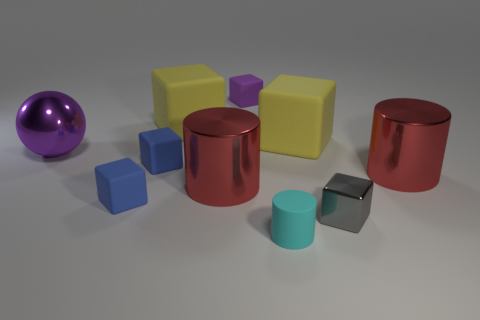There is a tiny thing that is the same color as the large ball; what is it made of?
Give a very brief answer. Rubber. There is a purple object that is the same size as the cyan cylinder; what is its shape?
Offer a very short reply. Cube. What color is the cylinder that is to the left of the purple cube?
Your answer should be compact. Red. What number of things are cubes that are behind the shiny ball or metallic cylinders right of the cyan cylinder?
Give a very brief answer. 4. Is the size of the gray object the same as the cyan rubber cylinder?
Provide a short and direct response. Yes. How many balls are big red things or large shiny objects?
Make the answer very short. 1. What number of metal objects are in front of the sphere and on the left side of the small gray block?
Provide a short and direct response. 1. Does the cyan cylinder have the same size as the yellow object that is left of the tiny cylinder?
Make the answer very short. No. Are there any large yellow rubber things that are to the left of the small rubber object that is in front of the gray object that is in front of the big shiny ball?
Your answer should be compact. Yes. There is a cylinder left of the tiny matte object in front of the small gray thing; what is its material?
Your answer should be very brief. Metal. 